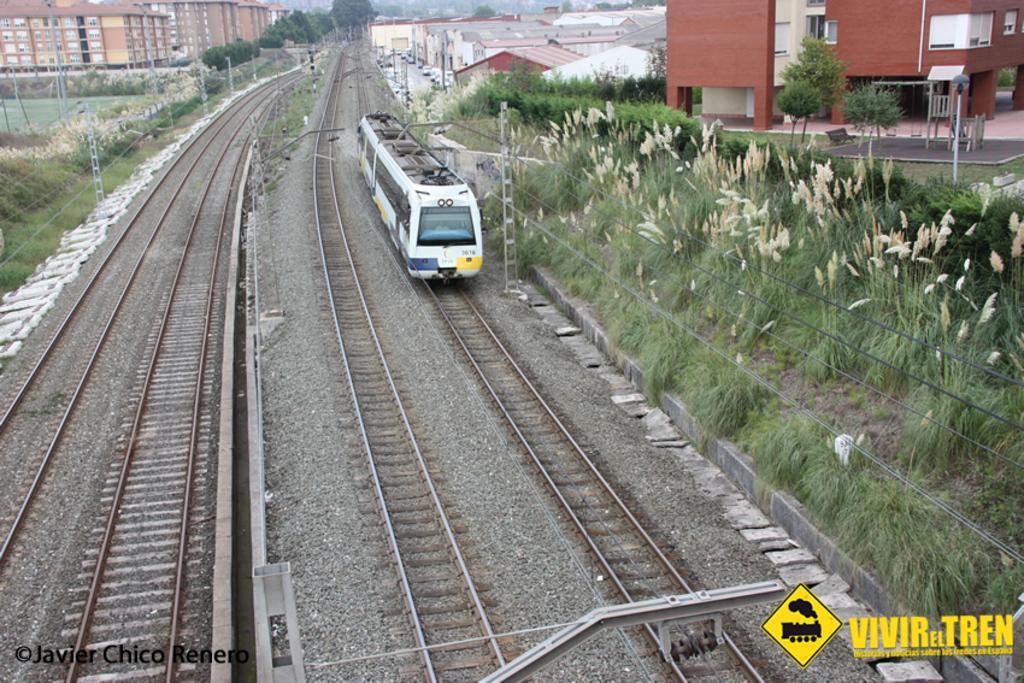Can you describe this image briefly? In this image I can see a railway track , on the track I can see a white color train and at the top I can see buildings and on the right side I can see grass and in front of the building I can see trees and power line poles visible on the left side. 